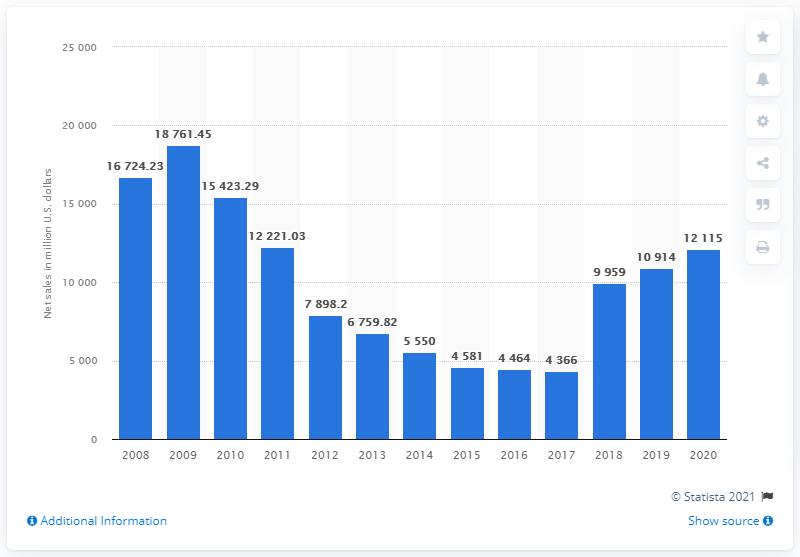Highlight a few significant elements in this photo. Nintendo's net sales in the United States in 2020 were approximately 121,150. Nintendo's net sales a year earlier were 10,914. 